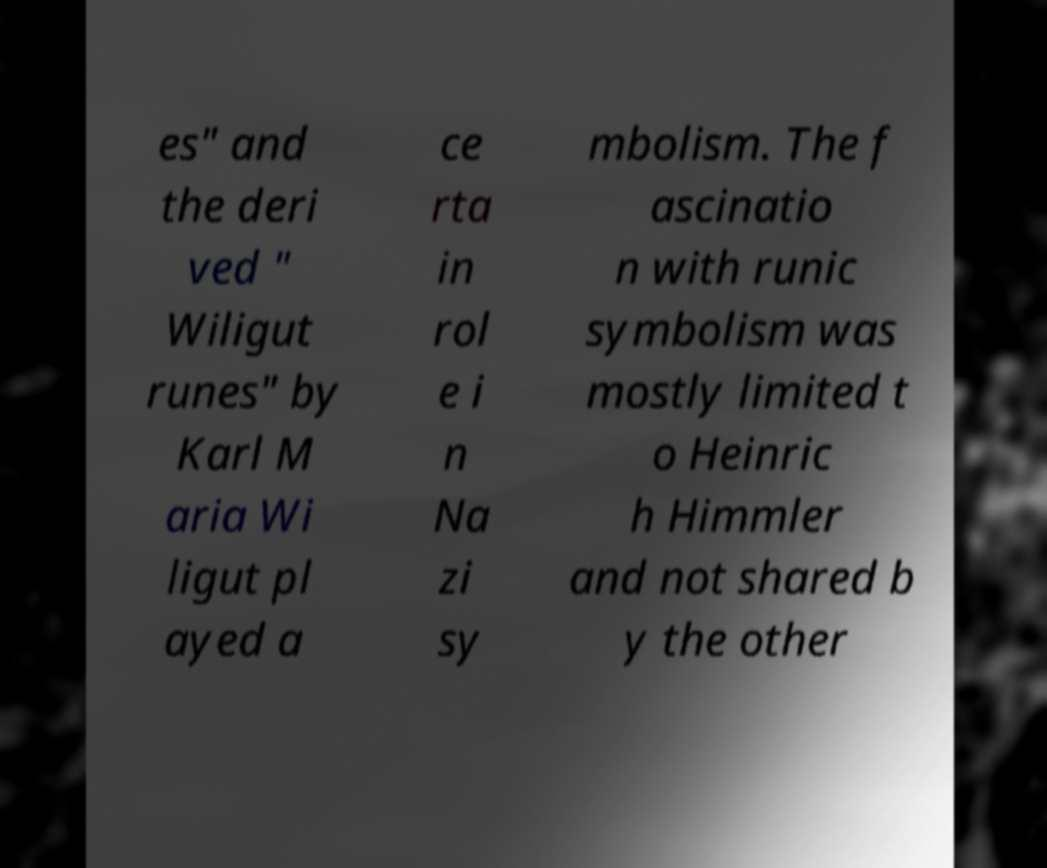Could you assist in decoding the text presented in this image and type it out clearly? es" and the deri ved " Wiligut runes" by Karl M aria Wi ligut pl ayed a ce rta in rol e i n Na zi sy mbolism. The f ascinatio n with runic symbolism was mostly limited t o Heinric h Himmler and not shared b y the other 